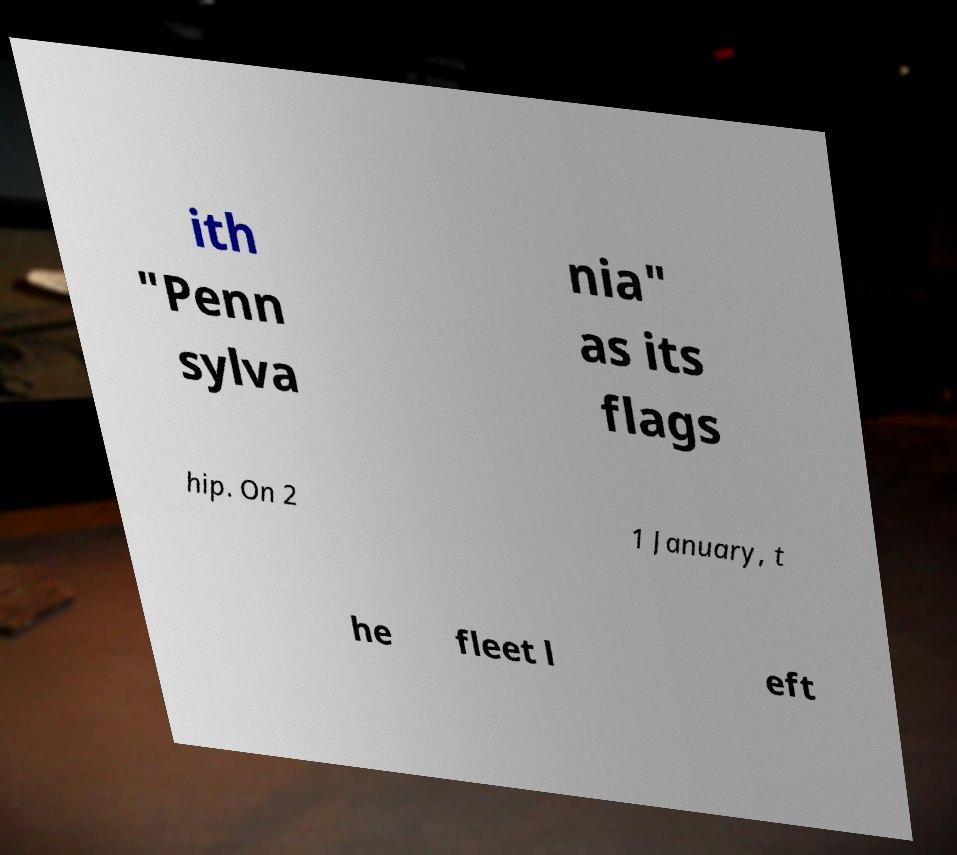Please identify and transcribe the text found in this image. ith "Penn sylva nia" as its flags hip. On 2 1 January, t he fleet l eft 